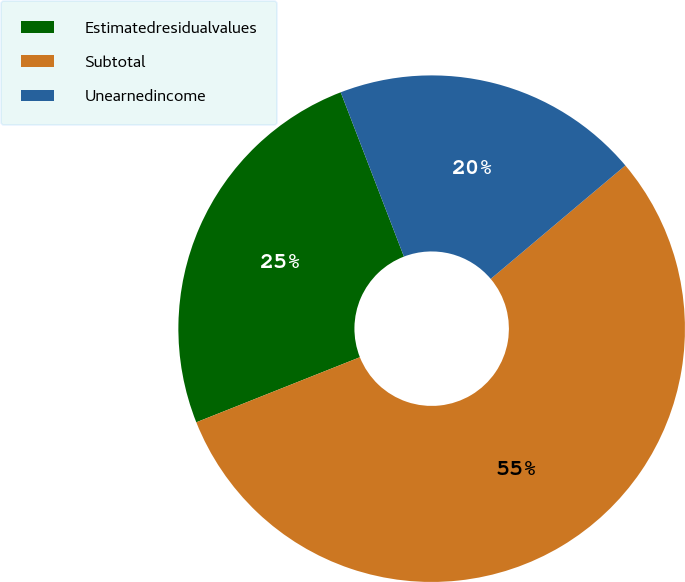Convert chart. <chart><loc_0><loc_0><loc_500><loc_500><pie_chart><fcel>Estimatedresidualvalues<fcel>Subtotal<fcel>Unearnedincome<nl><fcel>25.18%<fcel>55.12%<fcel>19.7%<nl></chart> 